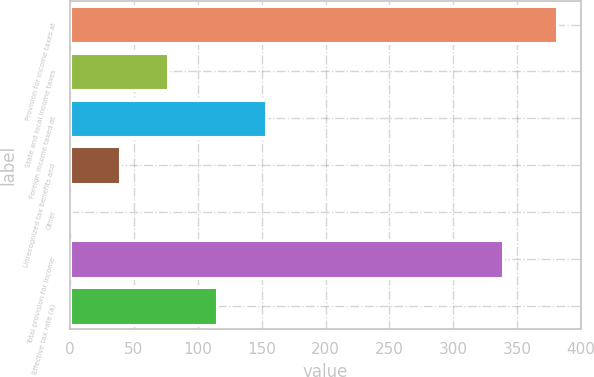<chart> <loc_0><loc_0><loc_500><loc_500><bar_chart><fcel>Provision for income taxes at<fcel>State and local income taxes<fcel>Foreign income taxed at<fcel>Unrecognized tax benefits and<fcel>Other<fcel>Total provision for income<fcel>Effective tax rate (a)<nl><fcel>381<fcel>77<fcel>153<fcel>39<fcel>1<fcel>339<fcel>115<nl></chart> 